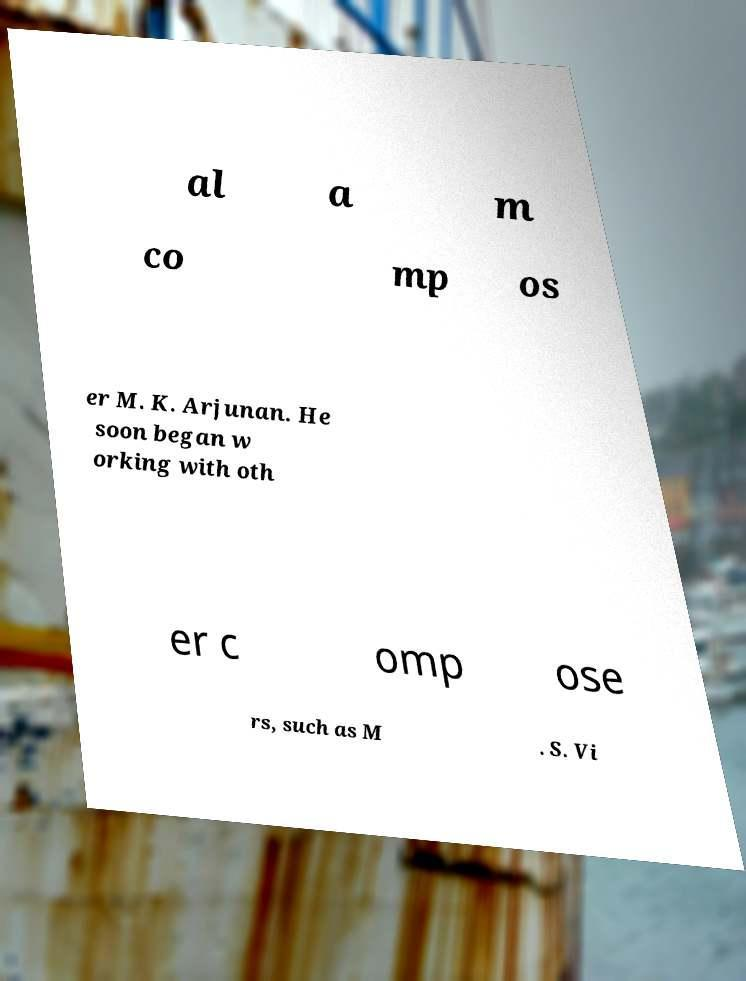Can you read and provide the text displayed in the image?This photo seems to have some interesting text. Can you extract and type it out for me? al a m co mp os er M. K. Arjunan. He soon began w orking with oth er c omp ose rs, such as M . S. Vi 